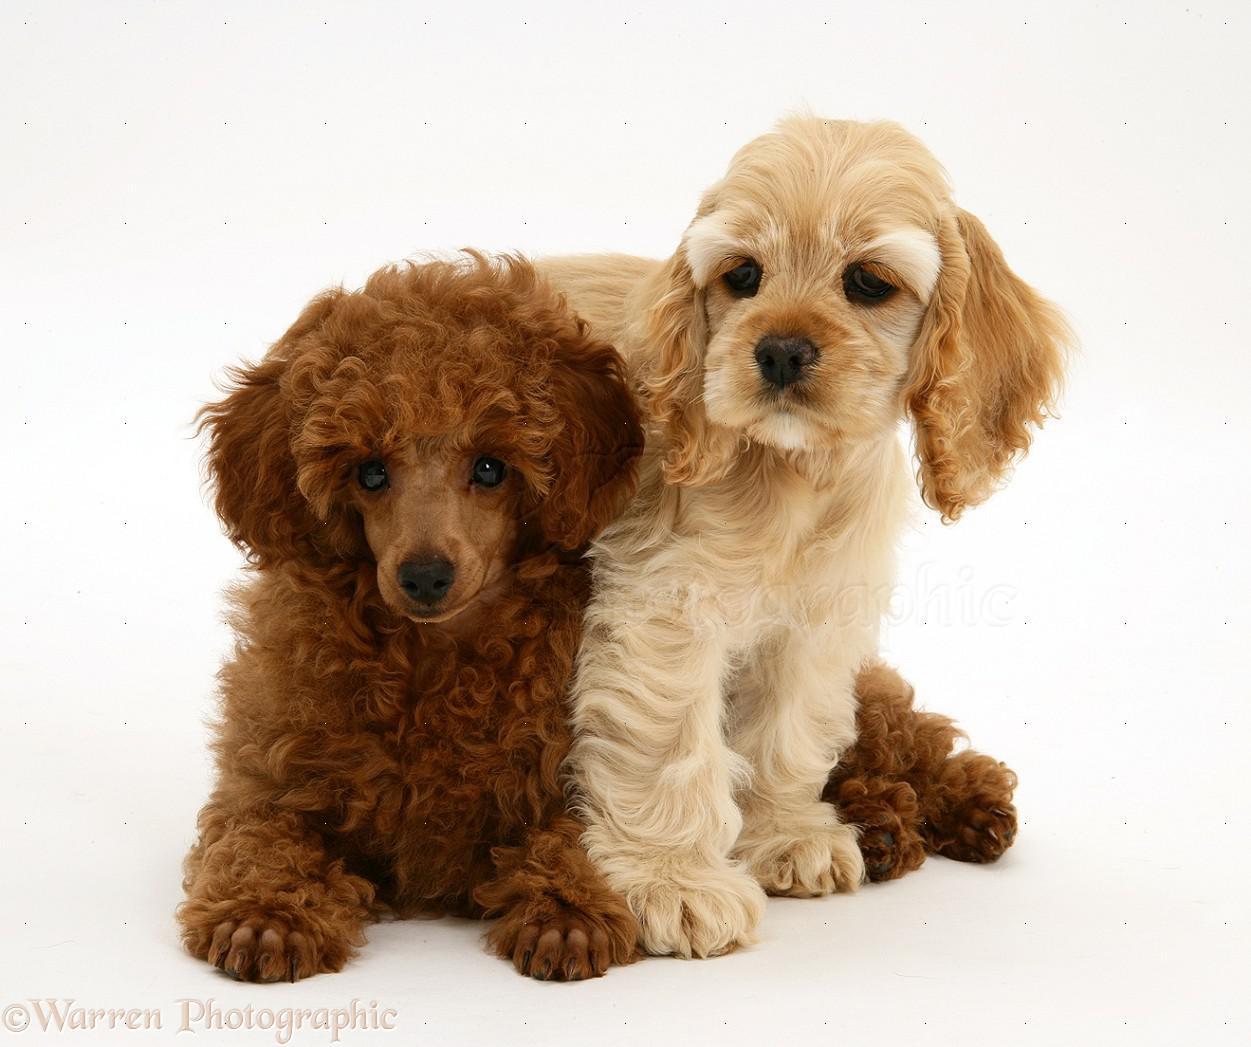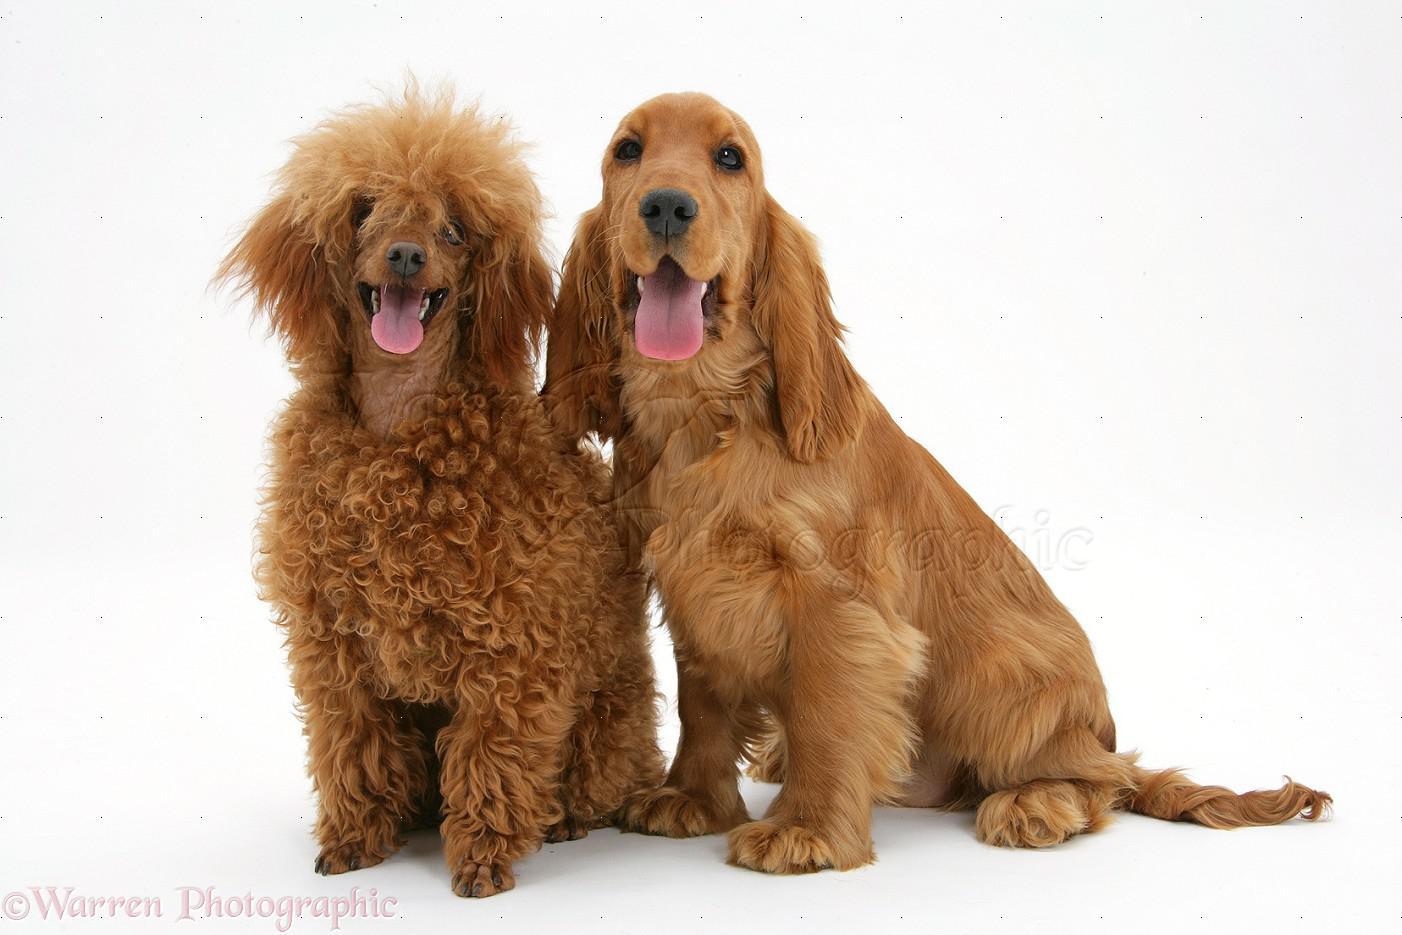The first image is the image on the left, the second image is the image on the right. For the images displayed, is the sentence "There are two dogs in the left image." factually correct? Answer yes or no. Yes. The first image is the image on the left, the second image is the image on the right. Assess this claim about the two images: "There is a young tan puppy on top of a curlyhaired brown puppy.". Correct or not? Answer yes or no. Yes. 